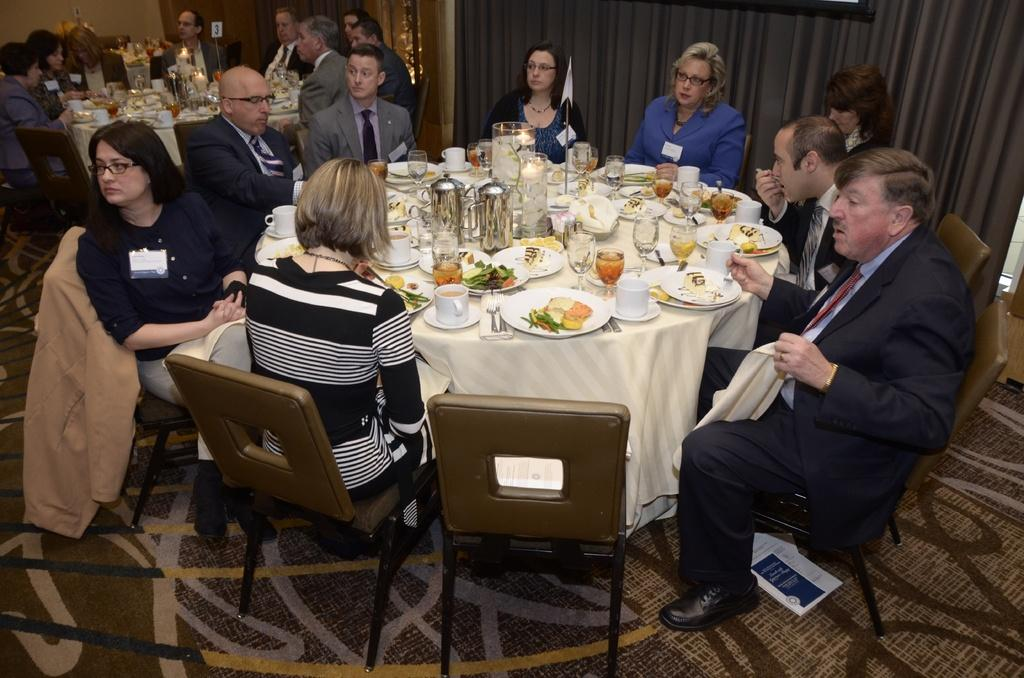What are the people in the image doing? There is a group of people sitting on chairs in the image. What items can be seen on the table in the image? On the table, there is a cup, a saucer, a spoon, a plate, food, a glass, and a jar. What might be used for stirring or eating in the image? The spoon on the table can be used for stirring or eating. What type of quill is being used to write on the plate in the image? There is no quill present in the image, and nothing is being written on the plate. How does the tooth compare to the size of the jar in the image? There is no tooth present in the image, so it cannot be compared to the size of the jar. 